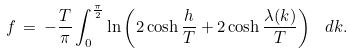Convert formula to latex. <formula><loc_0><loc_0><loc_500><loc_500>f \, = \, - \frac { T } { \pi } \int _ { 0 } ^ { \frac { \pi } { 2 } } \ln \left ( 2 \cosh \frac { h } { T } + 2 \cosh \frac { \lambda ( k ) } { T } \right ) \ d k .</formula> 